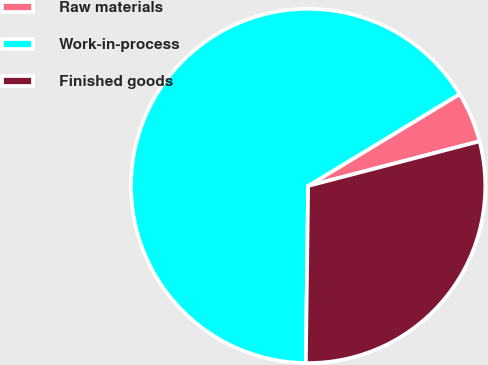Convert chart. <chart><loc_0><loc_0><loc_500><loc_500><pie_chart><fcel>Raw materials<fcel>Work-in-process<fcel>Finished goods<nl><fcel>4.62%<fcel>66.11%<fcel>29.26%<nl></chart> 